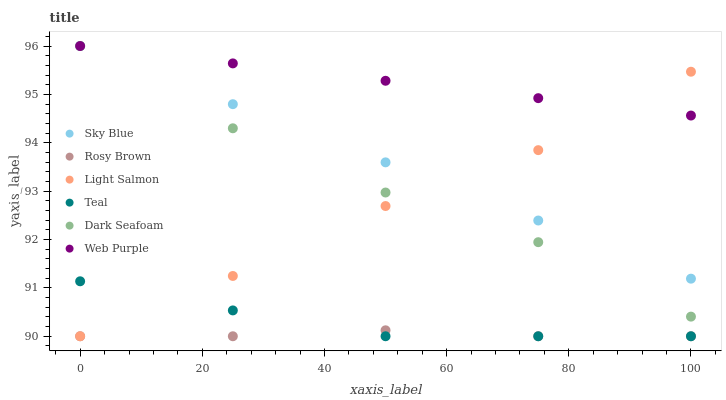Does Rosy Brown have the minimum area under the curve?
Answer yes or no. Yes. Does Web Purple have the maximum area under the curve?
Answer yes or no. Yes. Does Web Purple have the minimum area under the curve?
Answer yes or no. No. Does Rosy Brown have the maximum area under the curve?
Answer yes or no. No. Is Web Purple the smoothest?
Answer yes or no. Yes. Is Dark Seafoam the roughest?
Answer yes or no. Yes. Is Rosy Brown the smoothest?
Answer yes or no. No. Is Rosy Brown the roughest?
Answer yes or no. No. Does Light Salmon have the lowest value?
Answer yes or no. Yes. Does Web Purple have the lowest value?
Answer yes or no. No. Does Sky Blue have the highest value?
Answer yes or no. Yes. Does Rosy Brown have the highest value?
Answer yes or no. No. Is Rosy Brown less than Sky Blue?
Answer yes or no. Yes. Is Sky Blue greater than Rosy Brown?
Answer yes or no. Yes. Does Dark Seafoam intersect Web Purple?
Answer yes or no. Yes. Is Dark Seafoam less than Web Purple?
Answer yes or no. No. Is Dark Seafoam greater than Web Purple?
Answer yes or no. No. Does Rosy Brown intersect Sky Blue?
Answer yes or no. No. 